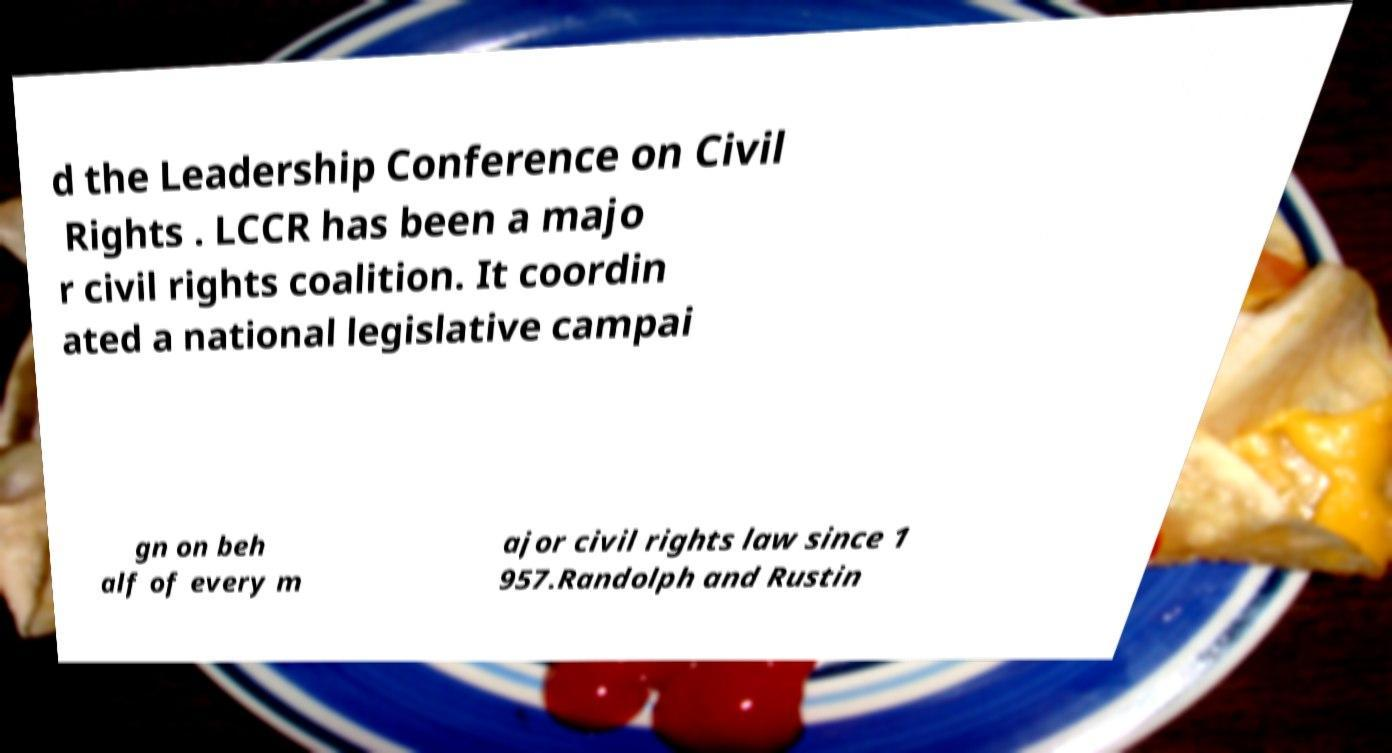Can you accurately transcribe the text from the provided image for me? d the Leadership Conference on Civil Rights . LCCR has been a majo r civil rights coalition. It coordin ated a national legislative campai gn on beh alf of every m ajor civil rights law since 1 957.Randolph and Rustin 